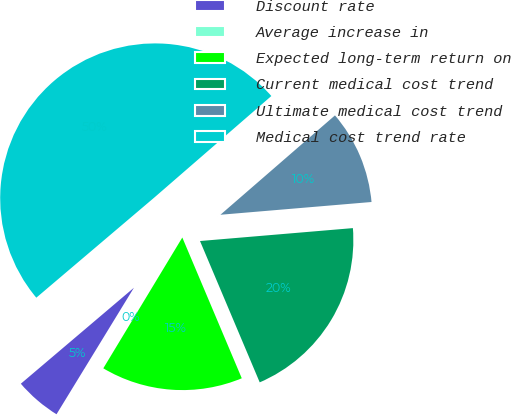Convert chart. <chart><loc_0><loc_0><loc_500><loc_500><pie_chart><fcel>Discount rate<fcel>Average increase in<fcel>Expected long-term return on<fcel>Current medical cost trend<fcel>Ultimate medical cost trend<fcel>Medical cost trend rate<nl><fcel>5.06%<fcel>0.09%<fcel>15.01%<fcel>19.98%<fcel>10.03%<fcel>49.83%<nl></chart> 